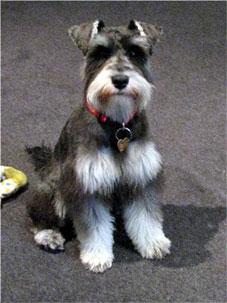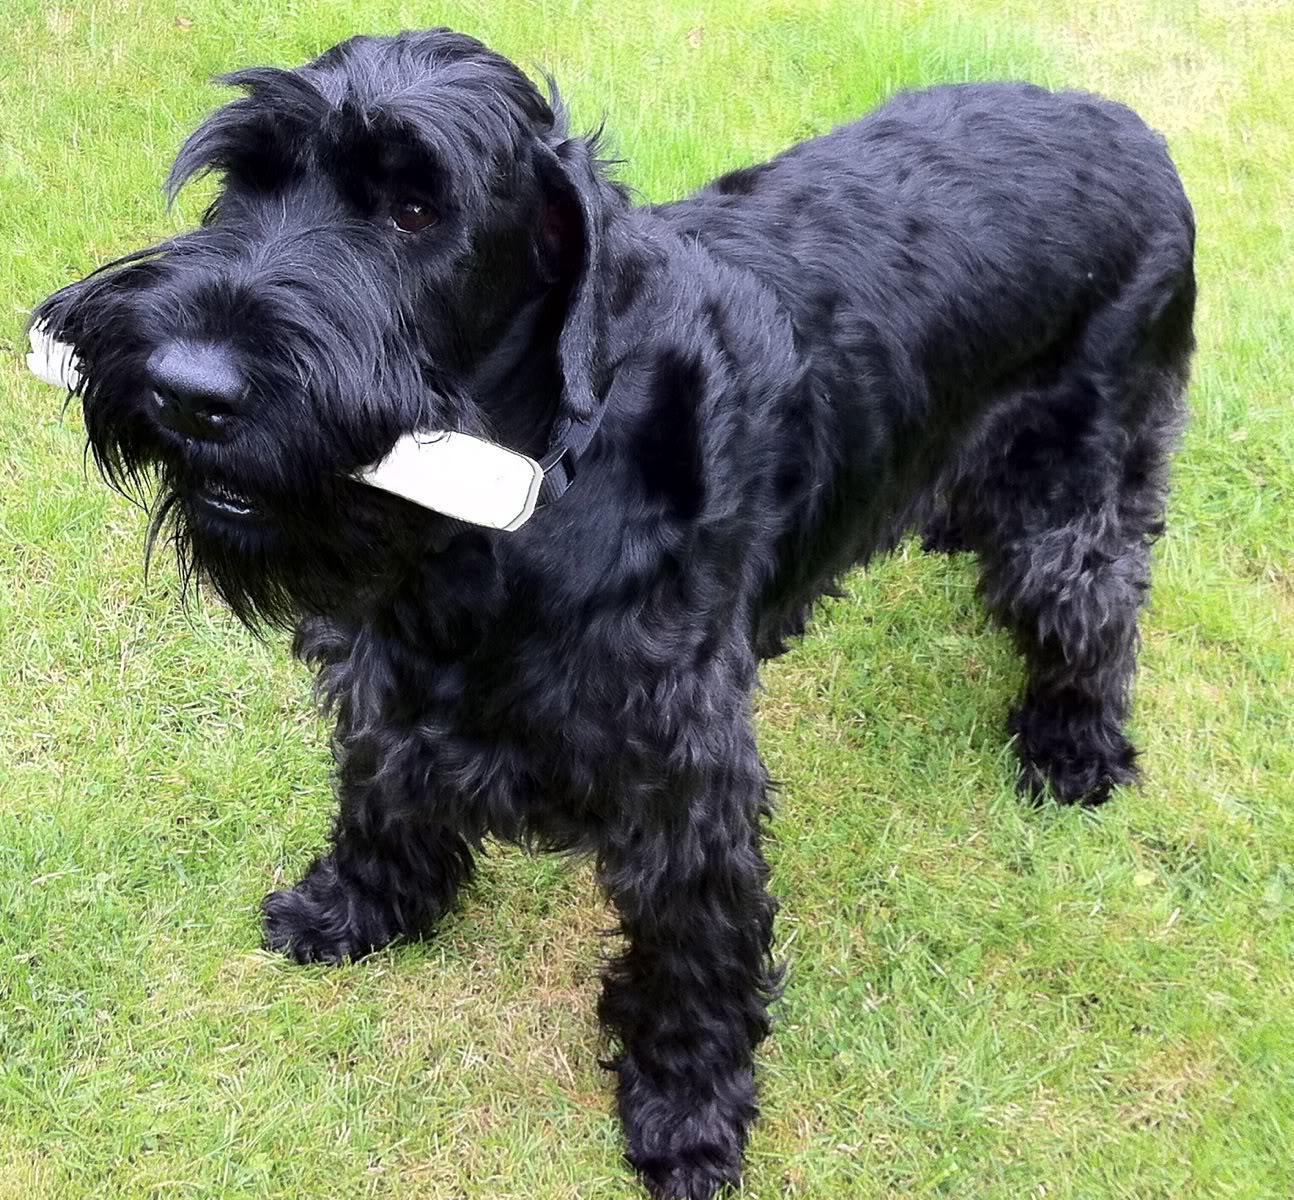The first image is the image on the left, the second image is the image on the right. Evaluate the accuracy of this statement regarding the images: "there is a black dog in the image on the right". Is it true? Answer yes or no. Yes. The first image is the image on the left, the second image is the image on the right. Evaluate the accuracy of this statement regarding the images: "There is an all black dog standing and facing to the right in one of the images.". Is it true? Answer yes or no. No. 